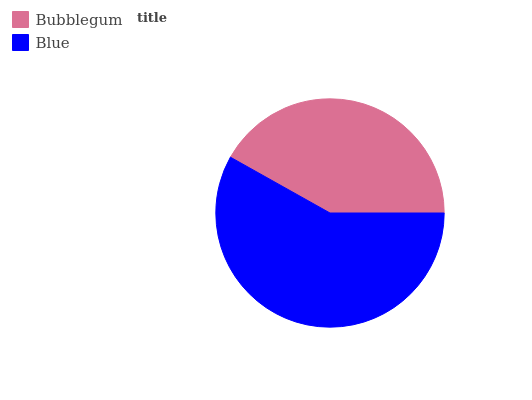Is Bubblegum the minimum?
Answer yes or no. Yes. Is Blue the maximum?
Answer yes or no. Yes. Is Blue the minimum?
Answer yes or no. No. Is Blue greater than Bubblegum?
Answer yes or no. Yes. Is Bubblegum less than Blue?
Answer yes or no. Yes. Is Bubblegum greater than Blue?
Answer yes or no. No. Is Blue less than Bubblegum?
Answer yes or no. No. Is Blue the high median?
Answer yes or no. Yes. Is Bubblegum the low median?
Answer yes or no. Yes. Is Bubblegum the high median?
Answer yes or no. No. Is Blue the low median?
Answer yes or no. No. 